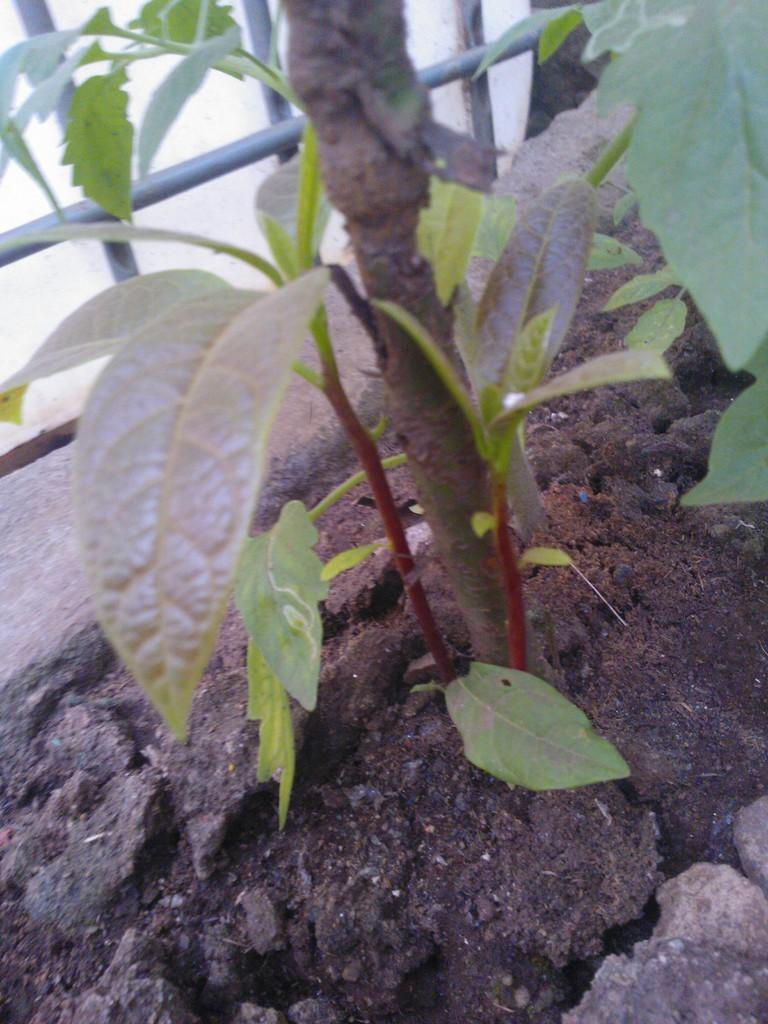What type of living organism is present in the image? There is a plant in the image. What objects are in front of the plant? There are rods in front of the plant. How many books are on the secretary's desk in the image? There is no secretary or desk present in the image; it only features a plant and rods. 